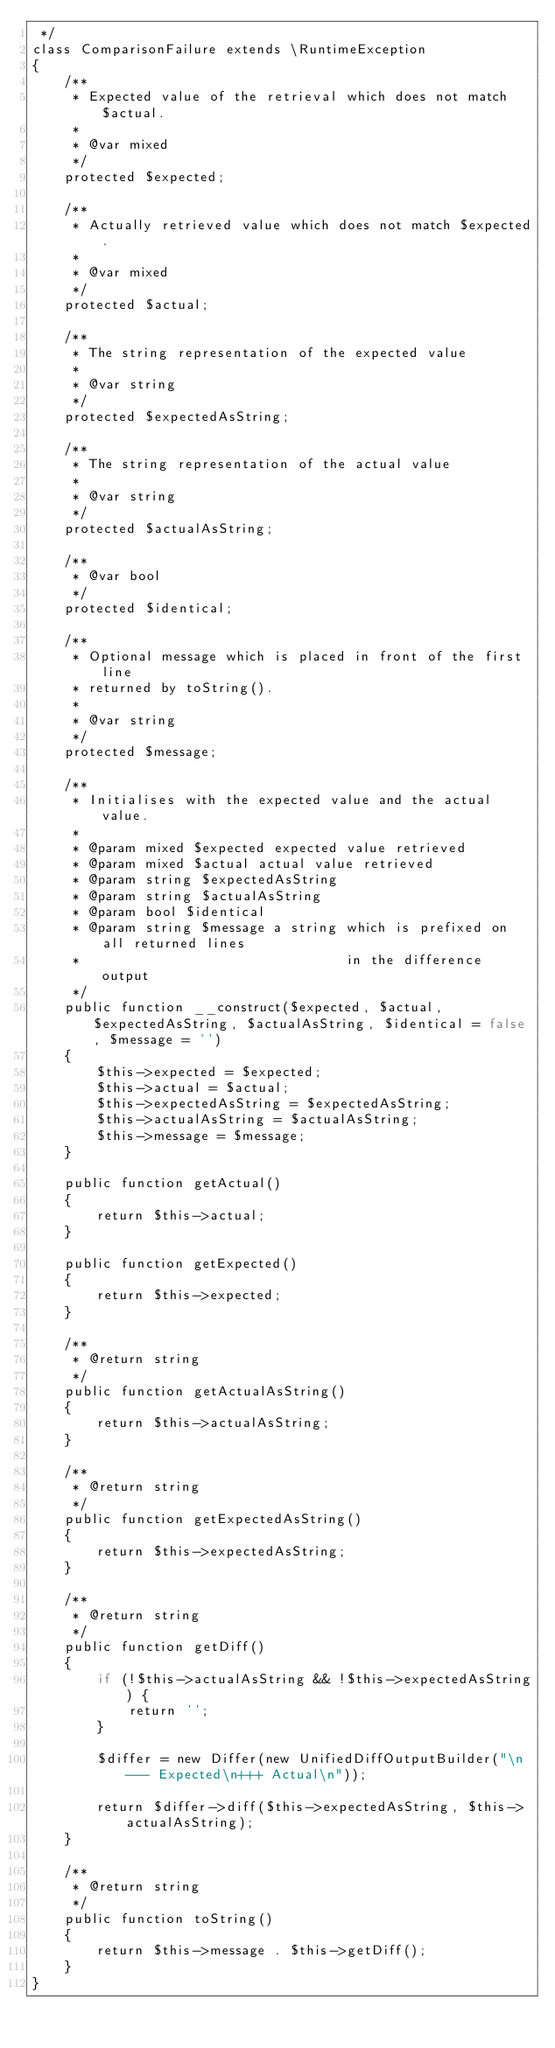Convert code to text. <code><loc_0><loc_0><loc_500><loc_500><_PHP_> */
class ComparisonFailure extends \RuntimeException
{
    /**
     * Expected value of the retrieval which does not match $actual.
     *
     * @var mixed
     */
    protected $expected;

    /**
     * Actually retrieved value which does not match $expected.
     *
     * @var mixed
     */
    protected $actual;

    /**
     * The string representation of the expected value
     *
     * @var string
     */
    protected $expectedAsString;

    /**
     * The string representation of the actual value
     *
     * @var string
     */
    protected $actualAsString;

    /**
     * @var bool
     */
    protected $identical;

    /**
     * Optional message which is placed in front of the first line
     * returned by toString().
     *
     * @var string
     */
    protected $message;

    /**
     * Initialises with the expected value and the actual value.
     *
     * @param mixed $expected expected value retrieved
     * @param mixed $actual actual value retrieved
     * @param string $expectedAsString
     * @param string $actualAsString
     * @param bool $identical
     * @param string $message a string which is prefixed on all returned lines
     *                                 in the difference output
     */
    public function __construct($expected, $actual, $expectedAsString, $actualAsString, $identical = false, $message = '')
    {
        $this->expected = $expected;
        $this->actual = $actual;
        $this->expectedAsString = $expectedAsString;
        $this->actualAsString = $actualAsString;
        $this->message = $message;
    }

    public function getActual()
    {
        return $this->actual;
    }

    public function getExpected()
    {
        return $this->expected;
    }

    /**
     * @return string
     */
    public function getActualAsString()
    {
        return $this->actualAsString;
    }

    /**
     * @return string
     */
    public function getExpectedAsString()
    {
        return $this->expectedAsString;
    }

    /**
     * @return string
     */
    public function getDiff()
    {
        if (!$this->actualAsString && !$this->expectedAsString) {
            return '';
        }

        $differ = new Differ(new UnifiedDiffOutputBuilder("\n--- Expected\n+++ Actual\n"));

        return $differ->diff($this->expectedAsString, $this->actualAsString);
    }

    /**
     * @return string
     */
    public function toString()
    {
        return $this->message . $this->getDiff();
    }
}
</code> 